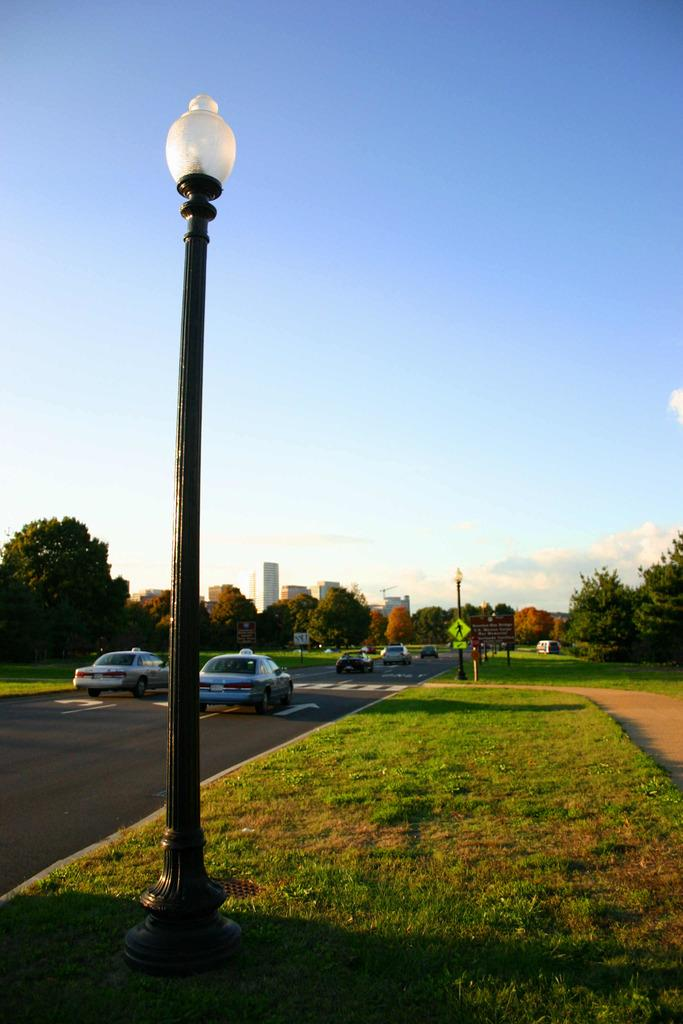What is located in the foreground of the image? There is a lamp pole and grassland in the foreground of the image. What can be seen in the background of the image? There are vehicles, poles, buildings, trees, and the sky visible in the background of the image. What type of mint is growing near the lamp pole in the image? There is no mint present in the image. What kind of soap can be seen being used by the people in the background of the image? There are no people or soap visible in the image. 